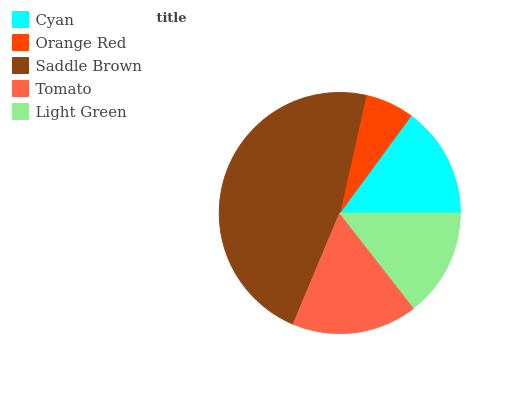Is Orange Red the minimum?
Answer yes or no. Yes. Is Saddle Brown the maximum?
Answer yes or no. Yes. Is Saddle Brown the minimum?
Answer yes or no. No. Is Orange Red the maximum?
Answer yes or no. No. Is Saddle Brown greater than Orange Red?
Answer yes or no. Yes. Is Orange Red less than Saddle Brown?
Answer yes or no. Yes. Is Orange Red greater than Saddle Brown?
Answer yes or no. No. Is Saddle Brown less than Orange Red?
Answer yes or no. No. Is Cyan the high median?
Answer yes or no. Yes. Is Cyan the low median?
Answer yes or no. Yes. Is Saddle Brown the high median?
Answer yes or no. No. Is Orange Red the low median?
Answer yes or no. No. 